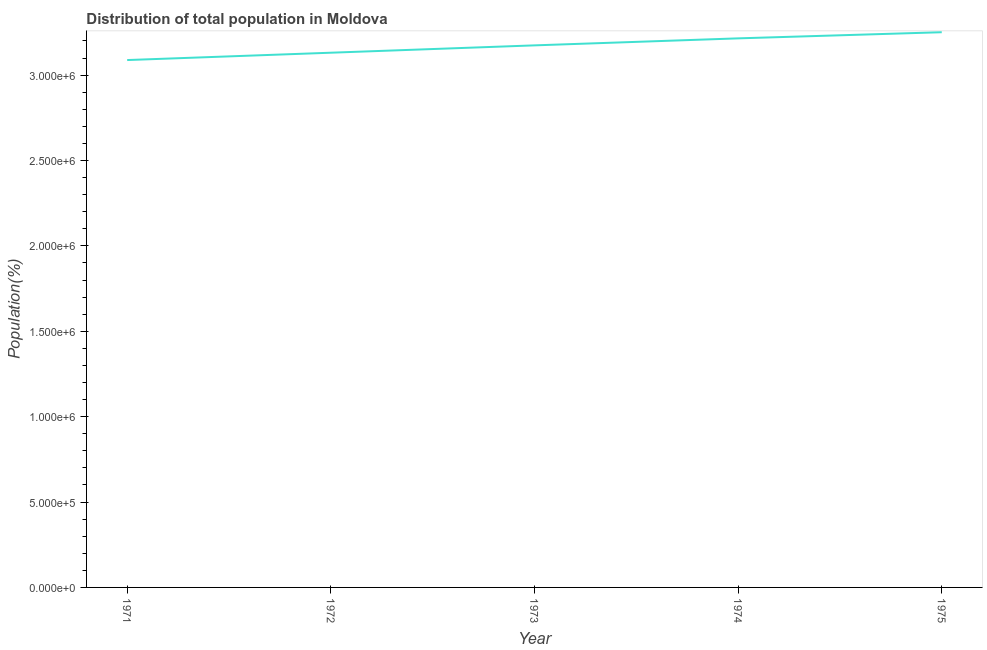What is the population in 1975?
Your answer should be compact. 3.25e+06. Across all years, what is the maximum population?
Provide a short and direct response. 3.25e+06. Across all years, what is the minimum population?
Provide a short and direct response. 3.09e+06. In which year was the population maximum?
Provide a short and direct response. 1975. In which year was the population minimum?
Offer a very short reply. 1971. What is the sum of the population?
Keep it short and to the point. 1.59e+07. What is the difference between the population in 1971 and 1972?
Your response must be concise. -4.30e+04. What is the average population per year?
Offer a terse response. 3.17e+06. What is the median population?
Offer a terse response. 3.17e+06. What is the ratio of the population in 1973 to that in 1975?
Give a very brief answer. 0.98. Is the population in 1971 less than that in 1974?
Your answer should be compact. Yes. Is the difference between the population in 1972 and 1974 greater than the difference between any two years?
Offer a terse response. No. What is the difference between the highest and the second highest population?
Offer a terse response. 3.60e+04. Is the sum of the population in 1972 and 1975 greater than the maximum population across all years?
Offer a terse response. Yes. What is the difference between the highest and the lowest population?
Offer a very short reply. 1.63e+05. Does the population monotonically increase over the years?
Offer a very short reply. Yes. How many lines are there?
Your answer should be compact. 1. How many years are there in the graph?
Provide a succinct answer. 5. What is the difference between two consecutive major ticks on the Y-axis?
Provide a succinct answer. 5.00e+05. Does the graph contain grids?
Your answer should be very brief. No. What is the title of the graph?
Ensure brevity in your answer.  Distribution of total population in Moldova . What is the label or title of the Y-axis?
Make the answer very short. Population(%). What is the Population(%) in 1971?
Keep it short and to the point. 3.09e+06. What is the Population(%) of 1972?
Your response must be concise. 3.13e+06. What is the Population(%) of 1973?
Your response must be concise. 3.17e+06. What is the Population(%) of 1974?
Offer a very short reply. 3.22e+06. What is the Population(%) of 1975?
Keep it short and to the point. 3.25e+06. What is the difference between the Population(%) in 1971 and 1972?
Make the answer very short. -4.30e+04. What is the difference between the Population(%) in 1971 and 1973?
Keep it short and to the point. -8.60e+04. What is the difference between the Population(%) in 1971 and 1974?
Offer a very short reply. -1.27e+05. What is the difference between the Population(%) in 1971 and 1975?
Offer a very short reply. -1.63e+05. What is the difference between the Population(%) in 1972 and 1973?
Ensure brevity in your answer.  -4.30e+04. What is the difference between the Population(%) in 1972 and 1974?
Your answer should be compact. -8.40e+04. What is the difference between the Population(%) in 1973 and 1974?
Provide a short and direct response. -4.10e+04. What is the difference between the Population(%) in 1973 and 1975?
Offer a terse response. -7.70e+04. What is the difference between the Population(%) in 1974 and 1975?
Provide a succinct answer. -3.60e+04. What is the ratio of the Population(%) in 1971 to that in 1972?
Make the answer very short. 0.99. What is the ratio of the Population(%) in 1971 to that in 1975?
Give a very brief answer. 0.95. What is the ratio of the Population(%) in 1972 to that in 1974?
Provide a succinct answer. 0.97. What is the ratio of the Population(%) in 1972 to that in 1975?
Keep it short and to the point. 0.96. What is the ratio of the Population(%) in 1973 to that in 1975?
Offer a terse response. 0.98. 